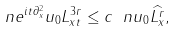<formula> <loc_0><loc_0><loc_500><loc_500>\ n { e ^ { i t \partial _ { x } ^ { 2 } } u _ { 0 } } { L ^ { 3 r } _ { x t } } \leq c \ n { u _ { 0 } } { \widehat { L ^ { r } _ { x } } } ,</formula> 